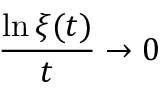Convert formula to latex. <formula><loc_0><loc_0><loc_500><loc_500>{ \frac { \ln \xi ( t ) } { t } } \to 0</formula> 